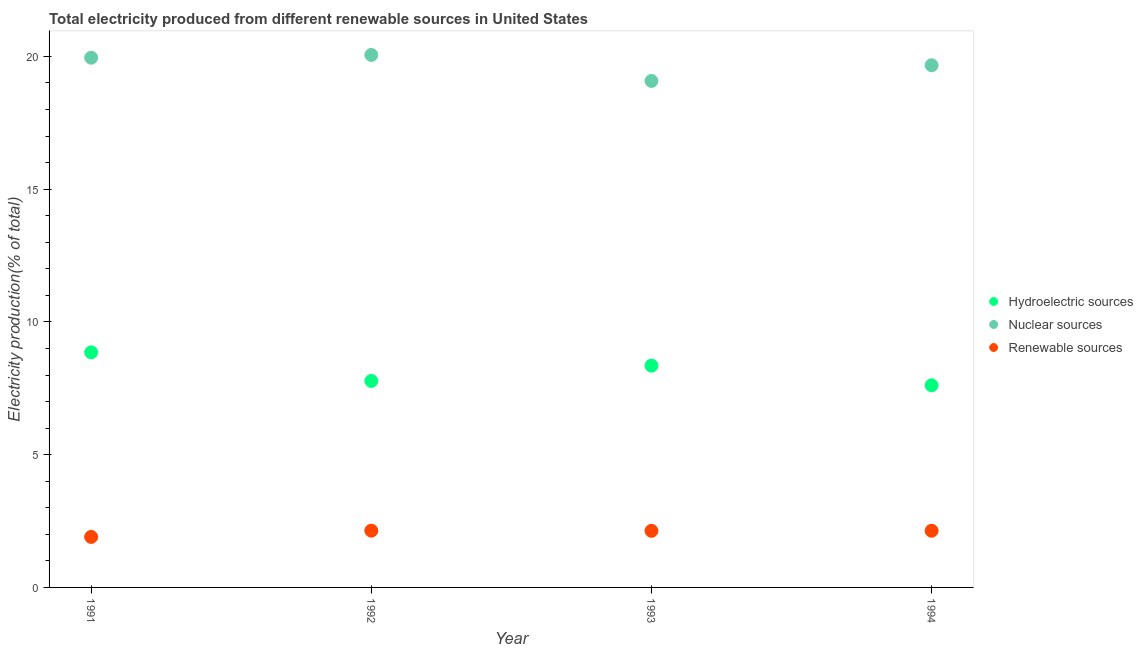How many different coloured dotlines are there?
Your answer should be very brief. 3. What is the percentage of electricity produced by nuclear sources in 1992?
Give a very brief answer. 20.06. Across all years, what is the maximum percentage of electricity produced by renewable sources?
Make the answer very short. 2.14. Across all years, what is the minimum percentage of electricity produced by renewable sources?
Make the answer very short. 1.9. In which year was the percentage of electricity produced by renewable sources minimum?
Your answer should be very brief. 1991. What is the total percentage of electricity produced by hydroelectric sources in the graph?
Your answer should be compact. 32.6. What is the difference between the percentage of electricity produced by hydroelectric sources in 1991 and that in 1994?
Offer a very short reply. 1.24. What is the difference between the percentage of electricity produced by nuclear sources in 1994 and the percentage of electricity produced by hydroelectric sources in 1992?
Give a very brief answer. 11.89. What is the average percentage of electricity produced by hydroelectric sources per year?
Ensure brevity in your answer.  8.15. In the year 1993, what is the difference between the percentage of electricity produced by nuclear sources and percentage of electricity produced by renewable sources?
Make the answer very short. 16.95. In how many years, is the percentage of electricity produced by nuclear sources greater than 14 %?
Your answer should be very brief. 4. What is the ratio of the percentage of electricity produced by renewable sources in 1991 to that in 1993?
Provide a short and direct response. 0.89. Is the difference between the percentage of electricity produced by hydroelectric sources in 1991 and 1992 greater than the difference between the percentage of electricity produced by nuclear sources in 1991 and 1992?
Ensure brevity in your answer.  Yes. What is the difference between the highest and the second highest percentage of electricity produced by nuclear sources?
Offer a very short reply. 0.11. What is the difference between the highest and the lowest percentage of electricity produced by nuclear sources?
Keep it short and to the point. 0.98. In how many years, is the percentage of electricity produced by nuclear sources greater than the average percentage of electricity produced by nuclear sources taken over all years?
Make the answer very short. 2. Is the percentage of electricity produced by nuclear sources strictly greater than the percentage of electricity produced by hydroelectric sources over the years?
Provide a short and direct response. Yes. Are the values on the major ticks of Y-axis written in scientific E-notation?
Your response must be concise. No. Does the graph contain grids?
Offer a very short reply. No. How many legend labels are there?
Give a very brief answer. 3. How are the legend labels stacked?
Your response must be concise. Vertical. What is the title of the graph?
Ensure brevity in your answer.  Total electricity produced from different renewable sources in United States. Does "Taxes on international trade" appear as one of the legend labels in the graph?
Your answer should be compact. No. What is the Electricity production(% of total) of Hydroelectric sources in 1991?
Your response must be concise. 8.85. What is the Electricity production(% of total) in Nuclear sources in 1991?
Offer a terse response. 19.95. What is the Electricity production(% of total) of Renewable sources in 1991?
Your answer should be compact. 1.9. What is the Electricity production(% of total) of Hydroelectric sources in 1992?
Offer a very short reply. 7.78. What is the Electricity production(% of total) in Nuclear sources in 1992?
Your response must be concise. 20.06. What is the Electricity production(% of total) in Renewable sources in 1992?
Keep it short and to the point. 2.14. What is the Electricity production(% of total) in Hydroelectric sources in 1993?
Give a very brief answer. 8.35. What is the Electricity production(% of total) of Nuclear sources in 1993?
Make the answer very short. 19.08. What is the Electricity production(% of total) of Renewable sources in 1993?
Keep it short and to the point. 2.13. What is the Electricity production(% of total) of Hydroelectric sources in 1994?
Provide a short and direct response. 7.61. What is the Electricity production(% of total) of Nuclear sources in 1994?
Provide a succinct answer. 19.67. What is the Electricity production(% of total) of Renewable sources in 1994?
Make the answer very short. 2.13. Across all years, what is the maximum Electricity production(% of total) in Hydroelectric sources?
Offer a terse response. 8.85. Across all years, what is the maximum Electricity production(% of total) of Nuclear sources?
Offer a terse response. 20.06. Across all years, what is the maximum Electricity production(% of total) of Renewable sources?
Keep it short and to the point. 2.14. Across all years, what is the minimum Electricity production(% of total) in Hydroelectric sources?
Provide a short and direct response. 7.61. Across all years, what is the minimum Electricity production(% of total) of Nuclear sources?
Offer a terse response. 19.08. Across all years, what is the minimum Electricity production(% of total) of Renewable sources?
Provide a succinct answer. 1.9. What is the total Electricity production(% of total) in Hydroelectric sources in the graph?
Ensure brevity in your answer.  32.6. What is the total Electricity production(% of total) of Nuclear sources in the graph?
Offer a very short reply. 78.75. What is the total Electricity production(% of total) of Renewable sources in the graph?
Make the answer very short. 8.31. What is the difference between the Electricity production(% of total) of Hydroelectric sources in 1991 and that in 1992?
Your answer should be compact. 1.08. What is the difference between the Electricity production(% of total) in Nuclear sources in 1991 and that in 1992?
Provide a short and direct response. -0.11. What is the difference between the Electricity production(% of total) of Renewable sources in 1991 and that in 1992?
Your answer should be compact. -0.24. What is the difference between the Electricity production(% of total) of Hydroelectric sources in 1991 and that in 1993?
Offer a terse response. 0.5. What is the difference between the Electricity production(% of total) in Nuclear sources in 1991 and that in 1993?
Give a very brief answer. 0.87. What is the difference between the Electricity production(% of total) of Renewable sources in 1991 and that in 1993?
Offer a terse response. -0.23. What is the difference between the Electricity production(% of total) in Hydroelectric sources in 1991 and that in 1994?
Keep it short and to the point. 1.24. What is the difference between the Electricity production(% of total) in Nuclear sources in 1991 and that in 1994?
Ensure brevity in your answer.  0.28. What is the difference between the Electricity production(% of total) of Renewable sources in 1991 and that in 1994?
Ensure brevity in your answer.  -0.23. What is the difference between the Electricity production(% of total) in Hydroelectric sources in 1992 and that in 1993?
Ensure brevity in your answer.  -0.58. What is the difference between the Electricity production(% of total) in Nuclear sources in 1992 and that in 1993?
Ensure brevity in your answer.  0.98. What is the difference between the Electricity production(% of total) in Renewable sources in 1992 and that in 1993?
Give a very brief answer. 0.01. What is the difference between the Electricity production(% of total) in Hydroelectric sources in 1992 and that in 1994?
Your response must be concise. 0.17. What is the difference between the Electricity production(% of total) in Nuclear sources in 1992 and that in 1994?
Provide a succinct answer. 0.39. What is the difference between the Electricity production(% of total) in Renewable sources in 1992 and that in 1994?
Your answer should be very brief. 0. What is the difference between the Electricity production(% of total) in Hydroelectric sources in 1993 and that in 1994?
Keep it short and to the point. 0.74. What is the difference between the Electricity production(% of total) of Nuclear sources in 1993 and that in 1994?
Your response must be concise. -0.59. What is the difference between the Electricity production(% of total) in Renewable sources in 1993 and that in 1994?
Provide a succinct answer. -0. What is the difference between the Electricity production(% of total) in Hydroelectric sources in 1991 and the Electricity production(% of total) in Nuclear sources in 1992?
Keep it short and to the point. -11.2. What is the difference between the Electricity production(% of total) of Hydroelectric sources in 1991 and the Electricity production(% of total) of Renewable sources in 1992?
Make the answer very short. 6.72. What is the difference between the Electricity production(% of total) in Nuclear sources in 1991 and the Electricity production(% of total) in Renewable sources in 1992?
Give a very brief answer. 17.81. What is the difference between the Electricity production(% of total) of Hydroelectric sources in 1991 and the Electricity production(% of total) of Nuclear sources in 1993?
Give a very brief answer. -10.22. What is the difference between the Electricity production(% of total) of Hydroelectric sources in 1991 and the Electricity production(% of total) of Renewable sources in 1993?
Make the answer very short. 6.72. What is the difference between the Electricity production(% of total) in Nuclear sources in 1991 and the Electricity production(% of total) in Renewable sources in 1993?
Ensure brevity in your answer.  17.82. What is the difference between the Electricity production(% of total) in Hydroelectric sources in 1991 and the Electricity production(% of total) in Nuclear sources in 1994?
Give a very brief answer. -10.81. What is the difference between the Electricity production(% of total) in Hydroelectric sources in 1991 and the Electricity production(% of total) in Renewable sources in 1994?
Your response must be concise. 6.72. What is the difference between the Electricity production(% of total) in Nuclear sources in 1991 and the Electricity production(% of total) in Renewable sources in 1994?
Your response must be concise. 17.82. What is the difference between the Electricity production(% of total) in Hydroelectric sources in 1992 and the Electricity production(% of total) in Nuclear sources in 1993?
Offer a very short reply. -11.3. What is the difference between the Electricity production(% of total) in Hydroelectric sources in 1992 and the Electricity production(% of total) in Renewable sources in 1993?
Your answer should be very brief. 5.65. What is the difference between the Electricity production(% of total) of Nuclear sources in 1992 and the Electricity production(% of total) of Renewable sources in 1993?
Offer a terse response. 17.93. What is the difference between the Electricity production(% of total) in Hydroelectric sources in 1992 and the Electricity production(% of total) in Nuclear sources in 1994?
Give a very brief answer. -11.89. What is the difference between the Electricity production(% of total) of Hydroelectric sources in 1992 and the Electricity production(% of total) of Renewable sources in 1994?
Provide a short and direct response. 5.64. What is the difference between the Electricity production(% of total) in Nuclear sources in 1992 and the Electricity production(% of total) in Renewable sources in 1994?
Your answer should be very brief. 17.92. What is the difference between the Electricity production(% of total) in Hydroelectric sources in 1993 and the Electricity production(% of total) in Nuclear sources in 1994?
Provide a succinct answer. -11.32. What is the difference between the Electricity production(% of total) of Hydroelectric sources in 1993 and the Electricity production(% of total) of Renewable sources in 1994?
Ensure brevity in your answer.  6.22. What is the difference between the Electricity production(% of total) in Nuclear sources in 1993 and the Electricity production(% of total) in Renewable sources in 1994?
Make the answer very short. 16.94. What is the average Electricity production(% of total) in Hydroelectric sources per year?
Keep it short and to the point. 8.15. What is the average Electricity production(% of total) of Nuclear sources per year?
Your answer should be very brief. 19.69. What is the average Electricity production(% of total) in Renewable sources per year?
Provide a short and direct response. 2.08. In the year 1991, what is the difference between the Electricity production(% of total) in Hydroelectric sources and Electricity production(% of total) in Nuclear sources?
Provide a short and direct response. -11.1. In the year 1991, what is the difference between the Electricity production(% of total) in Hydroelectric sources and Electricity production(% of total) in Renewable sources?
Your answer should be very brief. 6.95. In the year 1991, what is the difference between the Electricity production(% of total) in Nuclear sources and Electricity production(% of total) in Renewable sources?
Your answer should be compact. 18.05. In the year 1992, what is the difference between the Electricity production(% of total) in Hydroelectric sources and Electricity production(% of total) in Nuclear sources?
Your answer should be compact. -12.28. In the year 1992, what is the difference between the Electricity production(% of total) of Hydroelectric sources and Electricity production(% of total) of Renewable sources?
Your response must be concise. 5.64. In the year 1992, what is the difference between the Electricity production(% of total) in Nuclear sources and Electricity production(% of total) in Renewable sources?
Provide a succinct answer. 17.92. In the year 1993, what is the difference between the Electricity production(% of total) of Hydroelectric sources and Electricity production(% of total) of Nuclear sources?
Provide a succinct answer. -10.72. In the year 1993, what is the difference between the Electricity production(% of total) of Hydroelectric sources and Electricity production(% of total) of Renewable sources?
Your answer should be compact. 6.22. In the year 1993, what is the difference between the Electricity production(% of total) of Nuclear sources and Electricity production(% of total) of Renewable sources?
Provide a short and direct response. 16.95. In the year 1994, what is the difference between the Electricity production(% of total) of Hydroelectric sources and Electricity production(% of total) of Nuclear sources?
Your answer should be very brief. -12.06. In the year 1994, what is the difference between the Electricity production(% of total) in Hydroelectric sources and Electricity production(% of total) in Renewable sources?
Offer a terse response. 5.48. In the year 1994, what is the difference between the Electricity production(% of total) of Nuclear sources and Electricity production(% of total) of Renewable sources?
Offer a very short reply. 17.53. What is the ratio of the Electricity production(% of total) in Hydroelectric sources in 1991 to that in 1992?
Ensure brevity in your answer.  1.14. What is the ratio of the Electricity production(% of total) in Renewable sources in 1991 to that in 1992?
Make the answer very short. 0.89. What is the ratio of the Electricity production(% of total) of Hydroelectric sources in 1991 to that in 1993?
Offer a terse response. 1.06. What is the ratio of the Electricity production(% of total) of Nuclear sources in 1991 to that in 1993?
Provide a succinct answer. 1.05. What is the ratio of the Electricity production(% of total) of Renewable sources in 1991 to that in 1993?
Your answer should be compact. 0.89. What is the ratio of the Electricity production(% of total) in Hydroelectric sources in 1991 to that in 1994?
Offer a very short reply. 1.16. What is the ratio of the Electricity production(% of total) of Nuclear sources in 1991 to that in 1994?
Keep it short and to the point. 1.01. What is the ratio of the Electricity production(% of total) in Renewable sources in 1991 to that in 1994?
Your answer should be very brief. 0.89. What is the ratio of the Electricity production(% of total) of Hydroelectric sources in 1992 to that in 1993?
Make the answer very short. 0.93. What is the ratio of the Electricity production(% of total) of Nuclear sources in 1992 to that in 1993?
Provide a succinct answer. 1.05. What is the ratio of the Electricity production(% of total) in Hydroelectric sources in 1992 to that in 1994?
Offer a terse response. 1.02. What is the ratio of the Electricity production(% of total) of Nuclear sources in 1992 to that in 1994?
Make the answer very short. 1.02. What is the ratio of the Electricity production(% of total) of Hydroelectric sources in 1993 to that in 1994?
Give a very brief answer. 1.1. What is the ratio of the Electricity production(% of total) in Nuclear sources in 1993 to that in 1994?
Provide a succinct answer. 0.97. What is the ratio of the Electricity production(% of total) of Renewable sources in 1993 to that in 1994?
Provide a short and direct response. 1. What is the difference between the highest and the second highest Electricity production(% of total) of Hydroelectric sources?
Ensure brevity in your answer.  0.5. What is the difference between the highest and the second highest Electricity production(% of total) in Nuclear sources?
Ensure brevity in your answer.  0.11. What is the difference between the highest and the second highest Electricity production(% of total) in Renewable sources?
Your response must be concise. 0. What is the difference between the highest and the lowest Electricity production(% of total) in Hydroelectric sources?
Ensure brevity in your answer.  1.24. What is the difference between the highest and the lowest Electricity production(% of total) of Renewable sources?
Your answer should be very brief. 0.24. 